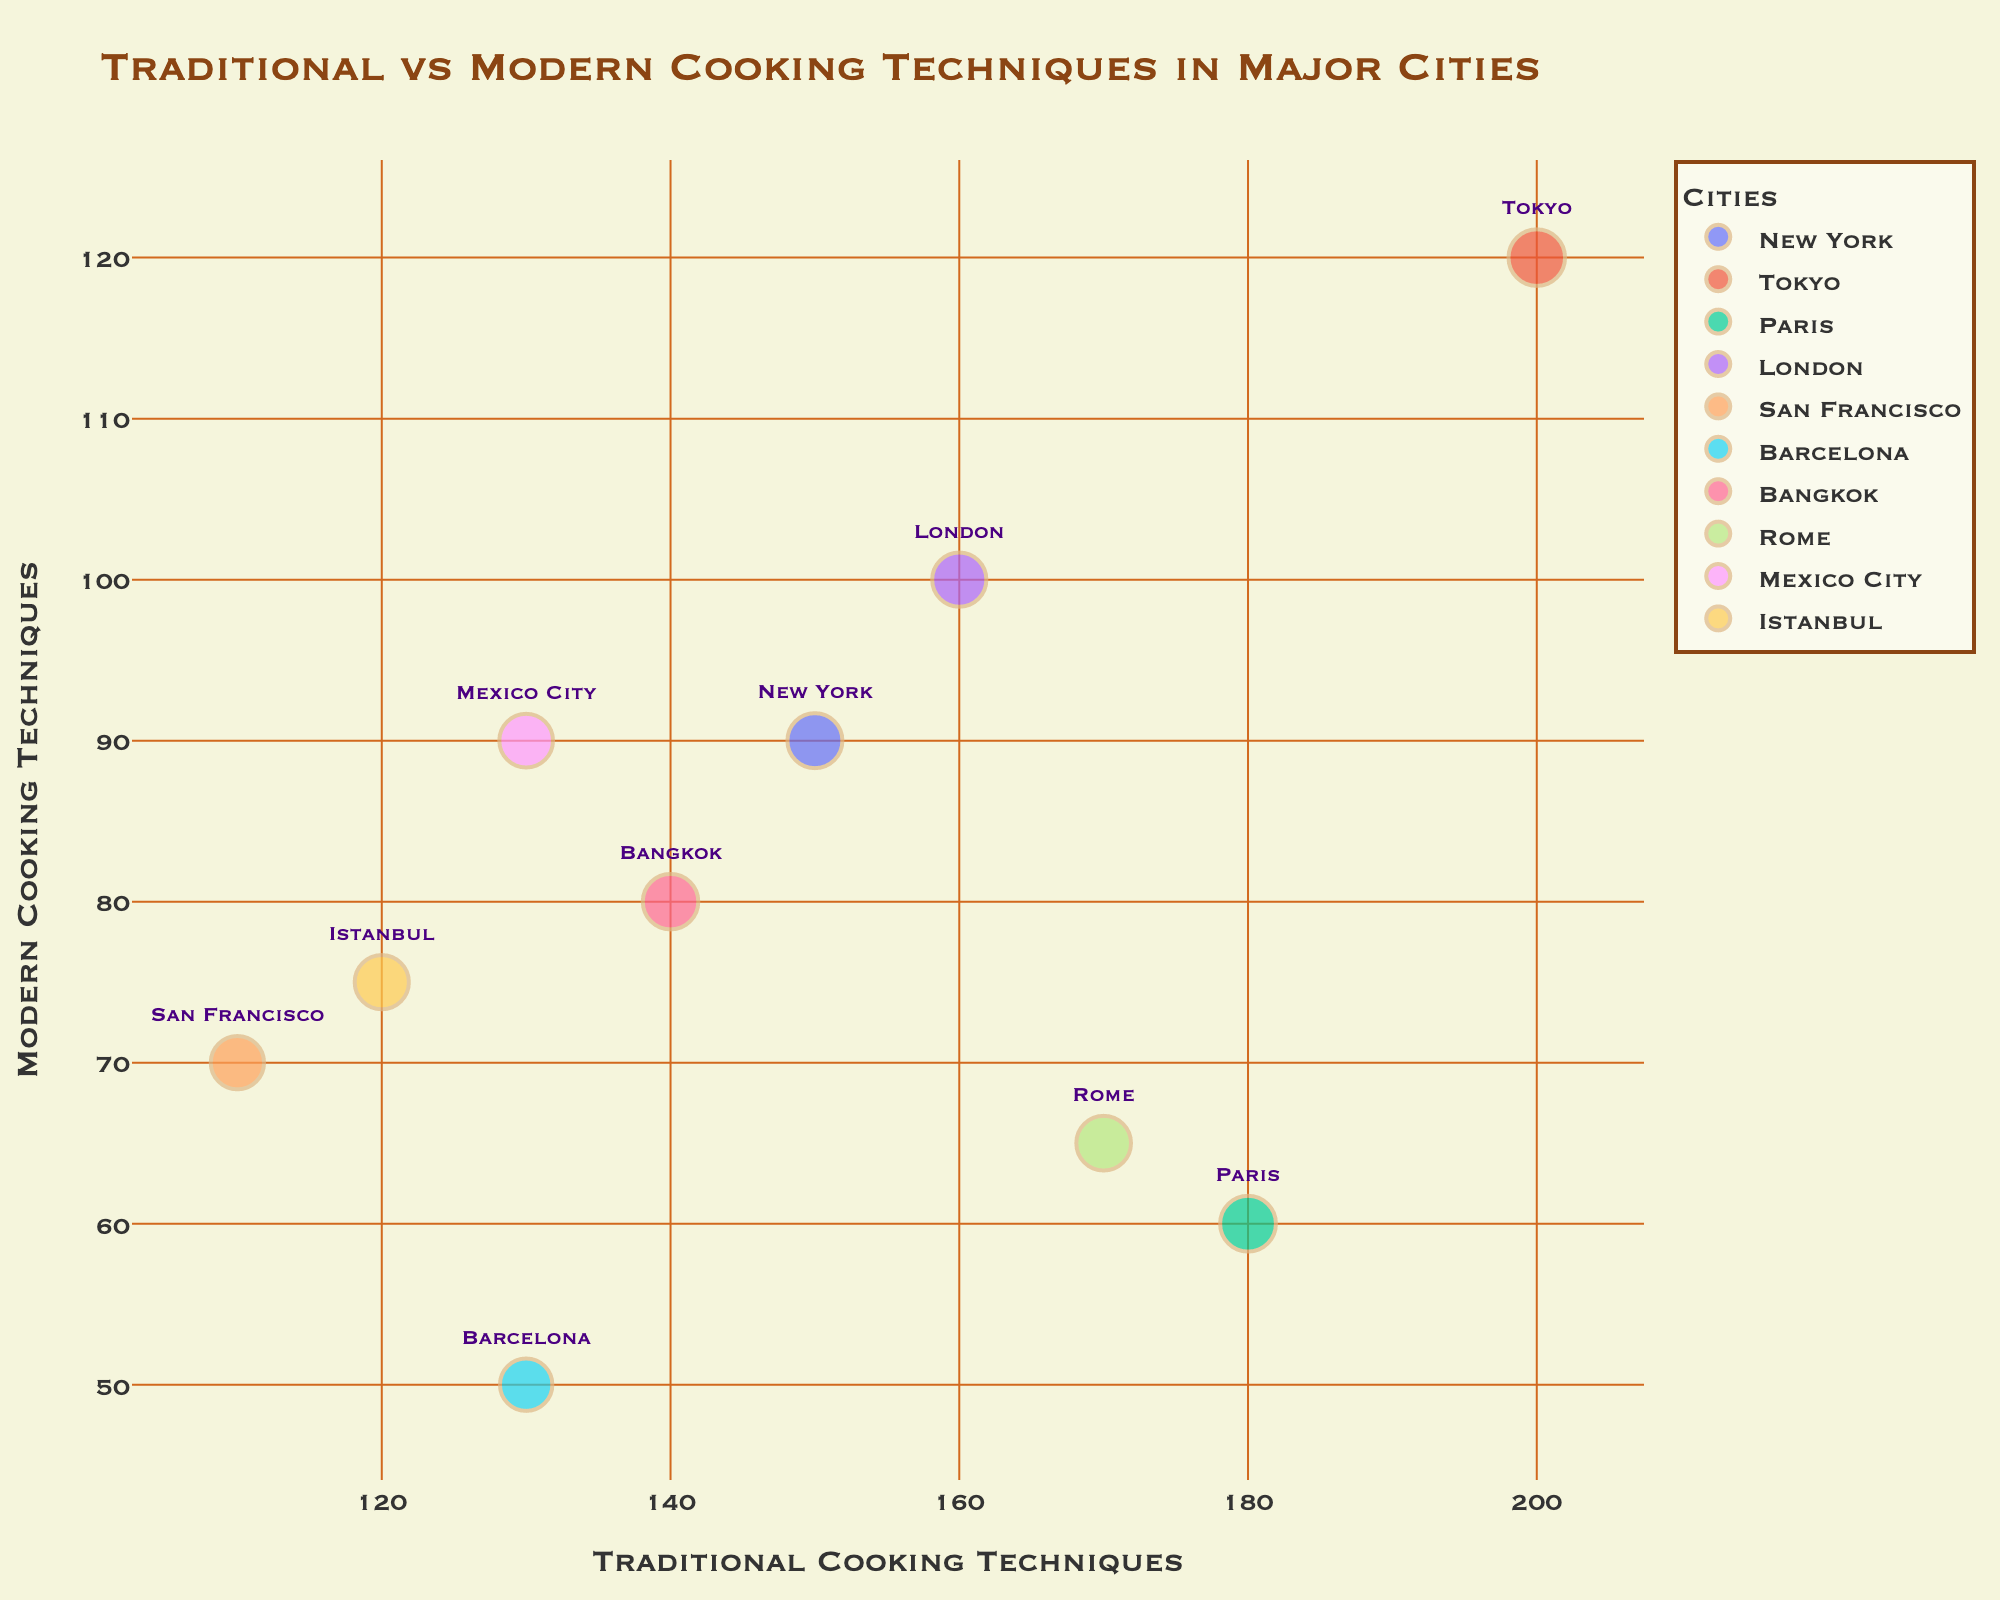Which city has the highest number of restaurants using traditional techniques? To find the city with the highest number of traditional techniques, look for the city with the highest value on the x-axis. Tokyo has the highest x-value at 200.
Answer: Tokyo Which city has the largest bubble size indicating the highest popularity score? The bubble size is proportional to the popularity score. The largest bubble represents the highest popularity score, which belongs to Tokyo, with a popularity score of 95.
Answer: Tokyo Which city has fewer restaurants using modern techniques, Paris or London? Compare the y-axis values of Paris and London. Paris has 60 while London has 100. Thus, Paris has fewer restaurants using modern techniques.
Answer: Paris What is the combined number of traditional and modern techniques in New York? Add the values of traditional techniques (150) and modern techniques (90) for New York. 150 + 90 = 240
Answer: 240 Which city has a higher ratio of traditional to modern techniques, Istanbul or San Francisco? Calculate the ratio of traditional to modern techniques for both cities. Istanbul: 120/75 = 1.6, San Francisco: 110/70 ≈ 1.57. Istanbul has a higher ratio.
Answer: Istanbul How many cities have more than 100 restaurants using traditional techniques? Count the cities with x-axis values greater than 100. The cities are New York, Tokyo, Paris, London, Bangkok, Rome, and Mexico City. There are 7 cities.
Answer: 7 Which city has the closest number of traditional and modern techniques? Look for cities where the x and y values are closest. New York has 150 traditional and 90 modern (difference = 60). Bangkok has 140 traditional and 80 modern (difference = 60). Both cities have the same difference.
Answer: New York, Bangkok Which city with less than 100 modern techniques has the highest popularity score? Filter cities with y-axis values less than 100 and compare their popularity scores. Paris has 60 modern techniques and a popularity score of 90, while others have lower scores.
Answer: Paris What is the total number of restaurants using traditional techniques across all cities? Sum the values of traditional techniques for all cities: 150 + 200 + 180 + 160 + 110 + 130 + 140 + 170 + 130 + 120 = 1490
Answer: 1490 Which city has more popularity, Rome or Barcelona? Compare the popularity scores listed in the hover data. Rome has 83, while Barcelona has 70. Rome is more popular.
Answer: Rome 